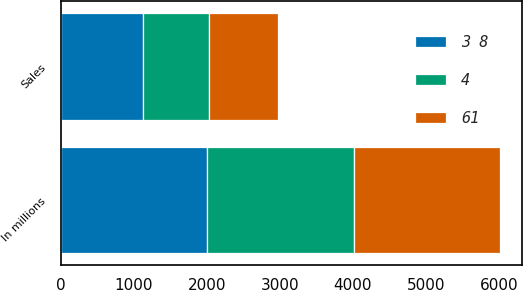Convert chart to OTSL. <chart><loc_0><loc_0><loc_500><loc_500><stacked_bar_chart><ecel><fcel>In millions<fcel>Sales<nl><fcel>61<fcel>2006<fcel>935<nl><fcel>4<fcel>2005<fcel>915<nl><fcel>3 8<fcel>2004<fcel>1120<nl></chart> 